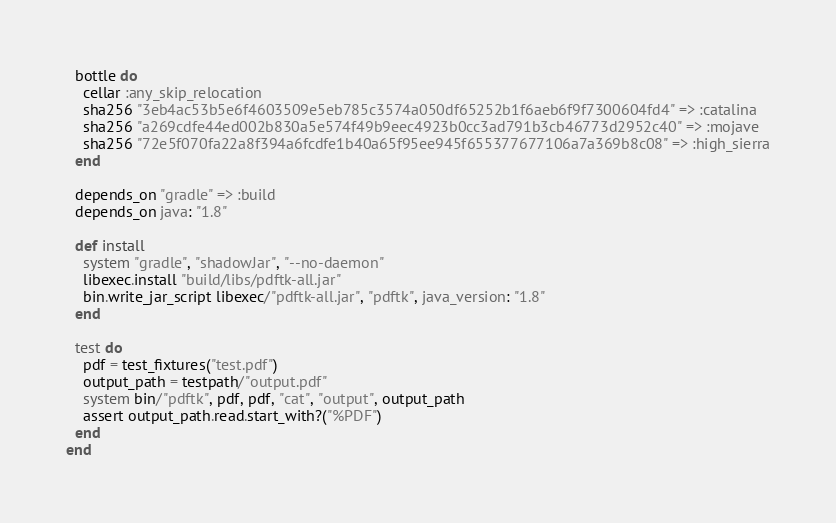<code> <loc_0><loc_0><loc_500><loc_500><_Ruby_>
  bottle do
    cellar :any_skip_relocation
    sha256 "3eb4ac53b5e6f4603509e5eb785c3574a050df65252b1f6aeb6f9f7300604fd4" => :catalina
    sha256 "a269cdfe44ed002b830a5e574f49b9eec4923b0cc3ad791b3cb46773d2952c40" => :mojave
    sha256 "72e5f070fa22a8f394a6fcdfe1b40a65f95ee945f655377677106a7a369b8c08" => :high_sierra
  end

  depends_on "gradle" => :build
  depends_on java: "1.8"

  def install
    system "gradle", "shadowJar", "--no-daemon"
    libexec.install "build/libs/pdftk-all.jar"
    bin.write_jar_script libexec/"pdftk-all.jar", "pdftk", java_version: "1.8"
  end

  test do
    pdf = test_fixtures("test.pdf")
    output_path = testpath/"output.pdf"
    system bin/"pdftk", pdf, pdf, "cat", "output", output_path
    assert output_path.read.start_with?("%PDF")
  end
end
</code> 